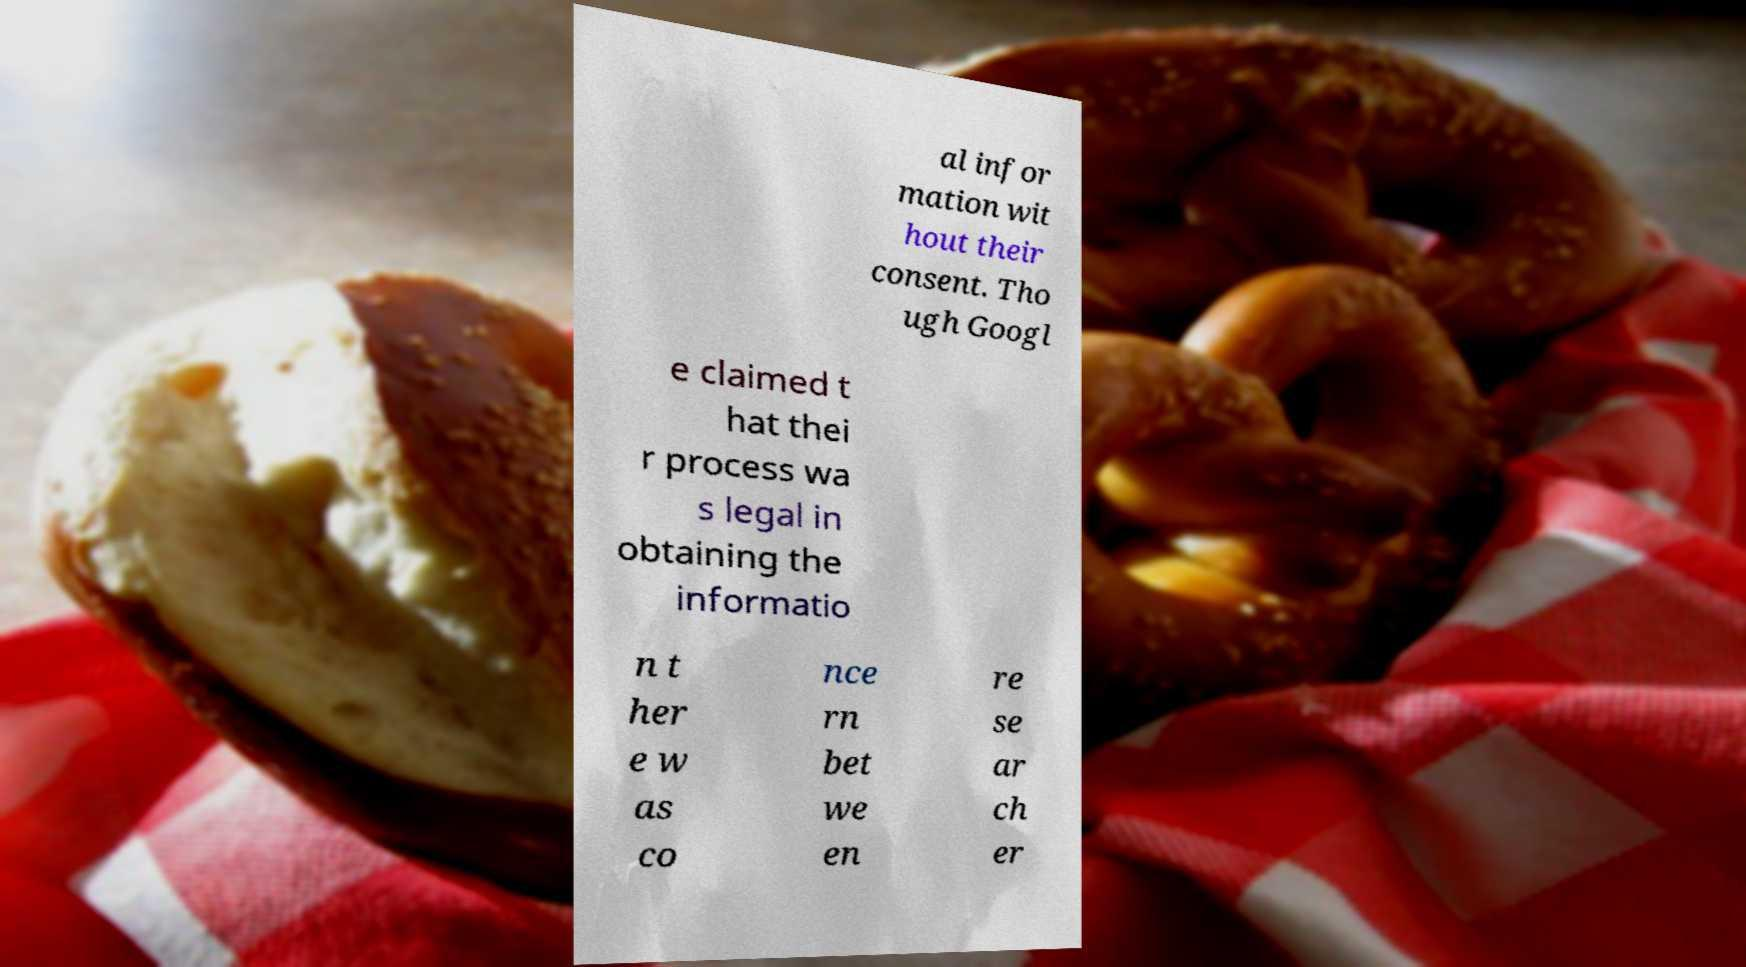Please identify and transcribe the text found in this image. al infor mation wit hout their consent. Tho ugh Googl e claimed t hat thei r process wa s legal in obtaining the informatio n t her e w as co nce rn bet we en re se ar ch er 